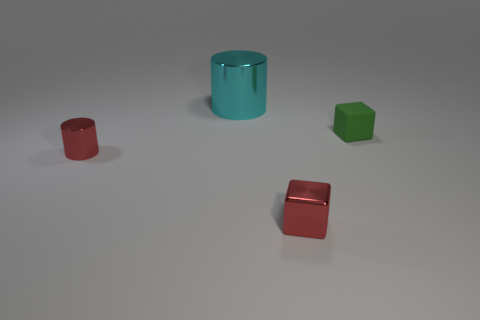Subtract all red cubes. How many cubes are left? 1 Add 1 tiny metallic objects. How many objects exist? 5 Subtract 2 blocks. How many blocks are left? 0 Add 2 blocks. How many blocks are left? 4 Add 2 cyan metal cylinders. How many cyan metal cylinders exist? 3 Subtract 0 brown spheres. How many objects are left? 4 Subtract all brown cylinders. Subtract all purple spheres. How many cylinders are left? 2 Subtract all cyan balls. How many cyan cylinders are left? 1 Subtract all large metallic objects. Subtract all tiny red cylinders. How many objects are left? 2 